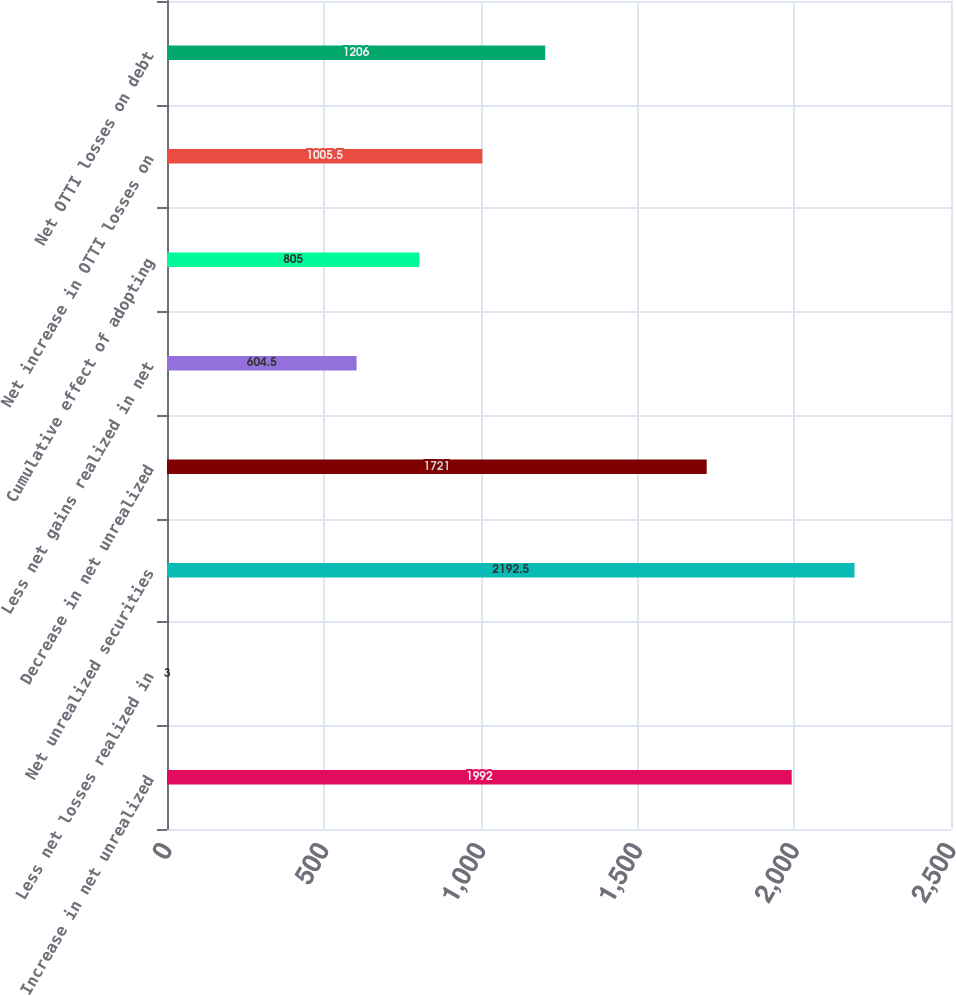Convert chart. <chart><loc_0><loc_0><loc_500><loc_500><bar_chart><fcel>Increase in net unrealized<fcel>Less net losses realized in<fcel>Net unrealized securities<fcel>Decrease in net unrealized<fcel>Less net gains realized in net<fcel>Cumulative effect of adopting<fcel>Net increase in OTTI losses on<fcel>Net OTTI losses on debt<nl><fcel>1992<fcel>3<fcel>2192.5<fcel>1721<fcel>604.5<fcel>805<fcel>1005.5<fcel>1206<nl></chart> 